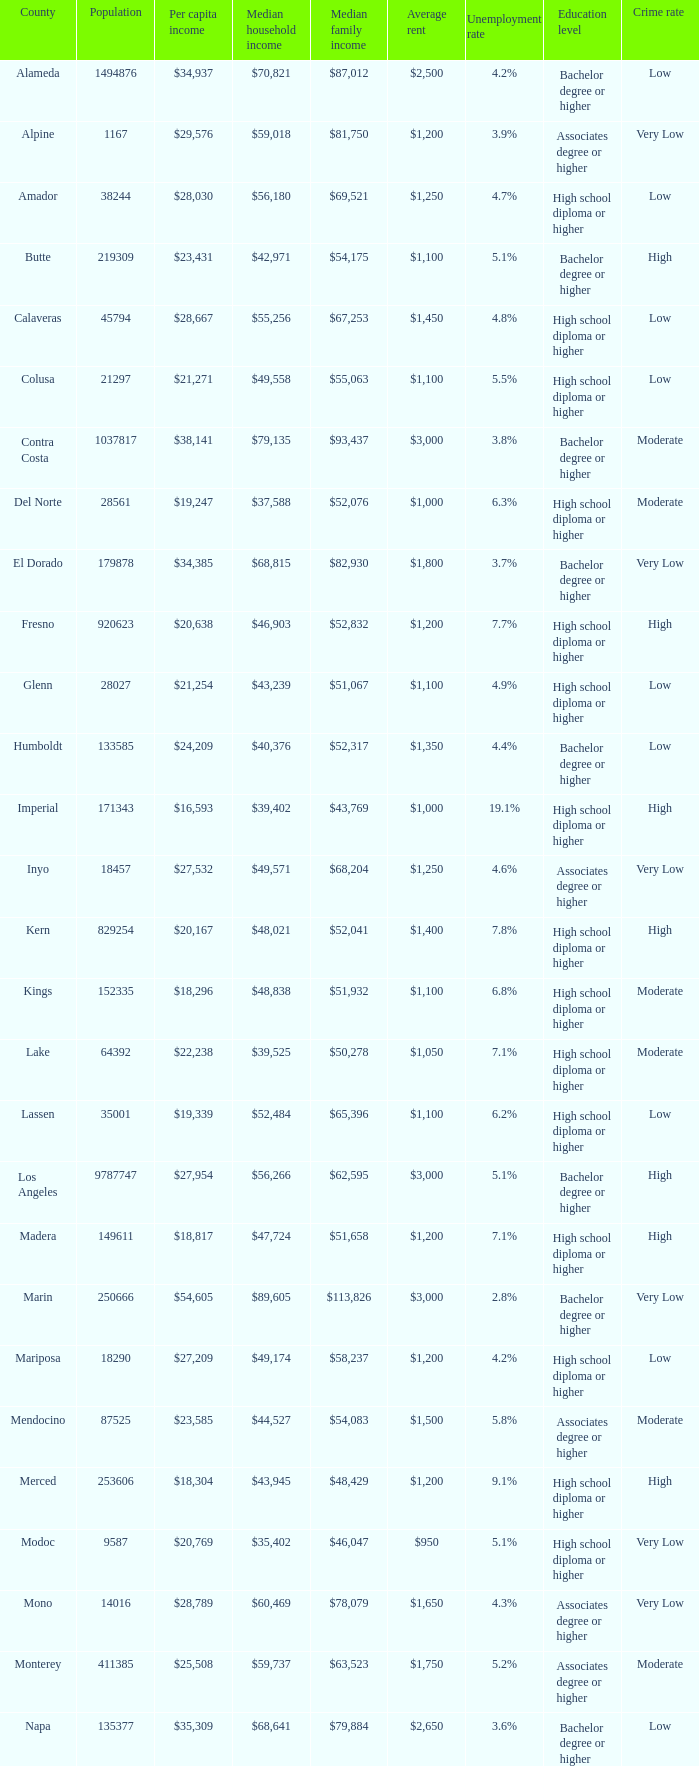State the central family income for riverside. $65,457. 